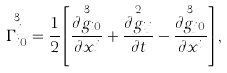Convert formula to latex. <formula><loc_0><loc_0><loc_500><loc_500>\overset { 3 } { \Gamma _ { i 0 } ^ { j } } = \frac { 1 } { 2 } \left [ \overset { 3 } { \frac { \partial g _ { i 0 } } { \partial x ^ { j } } } + \overset { 2 } { \frac { \partial g _ { i j } } { \partial t } } - \overset { 3 } { \frac { \partial g _ { j 0 } } { \partial x ^ { i } } } \right ] ,</formula> 